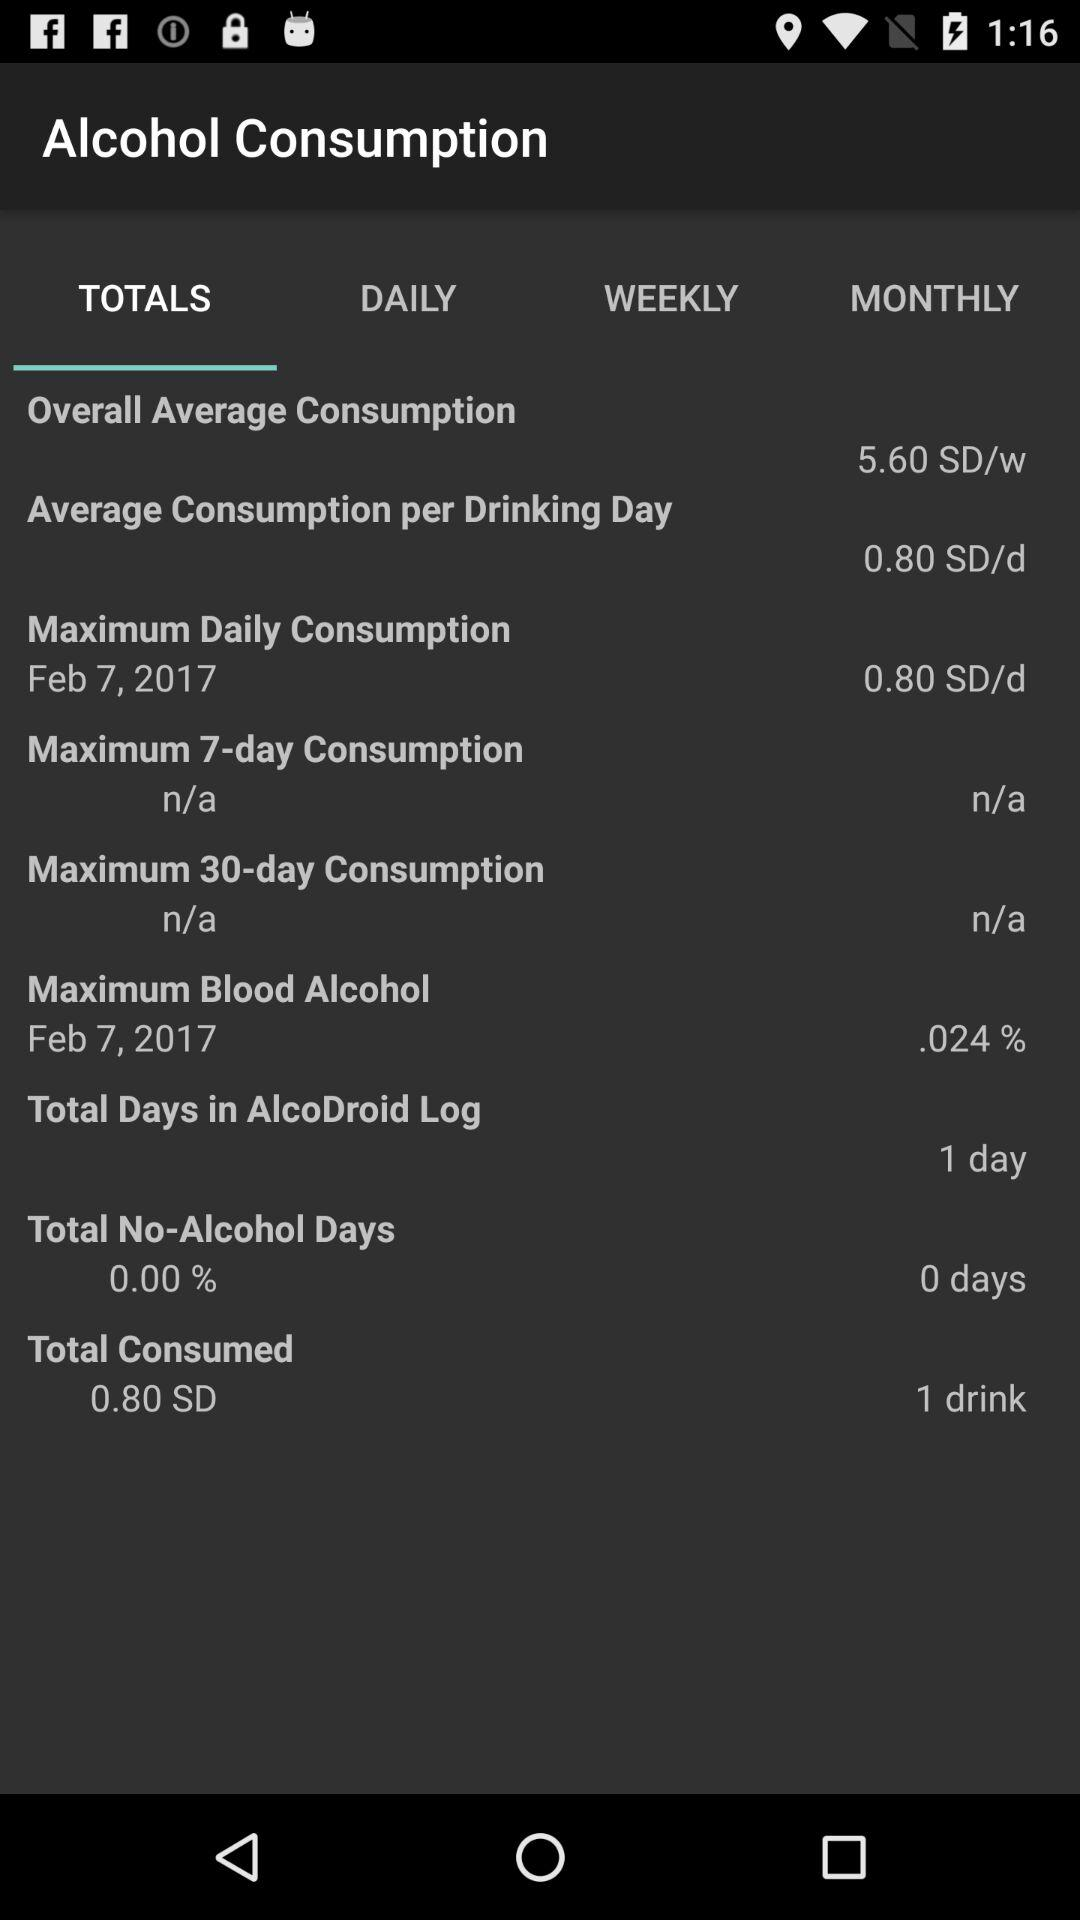What is the selected tab? The selected tab is "TOTALS". 